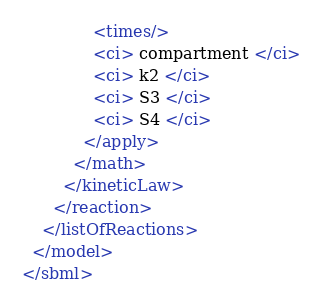<code> <loc_0><loc_0><loc_500><loc_500><_XML_>              <times/>
              <ci> compartment </ci>
              <ci> k2 </ci>
              <ci> S3 </ci>
              <ci> S4 </ci>
            </apply>
          </math>
        </kineticLaw>
      </reaction>
    </listOfReactions>
  </model>
</sbml>
</code> 